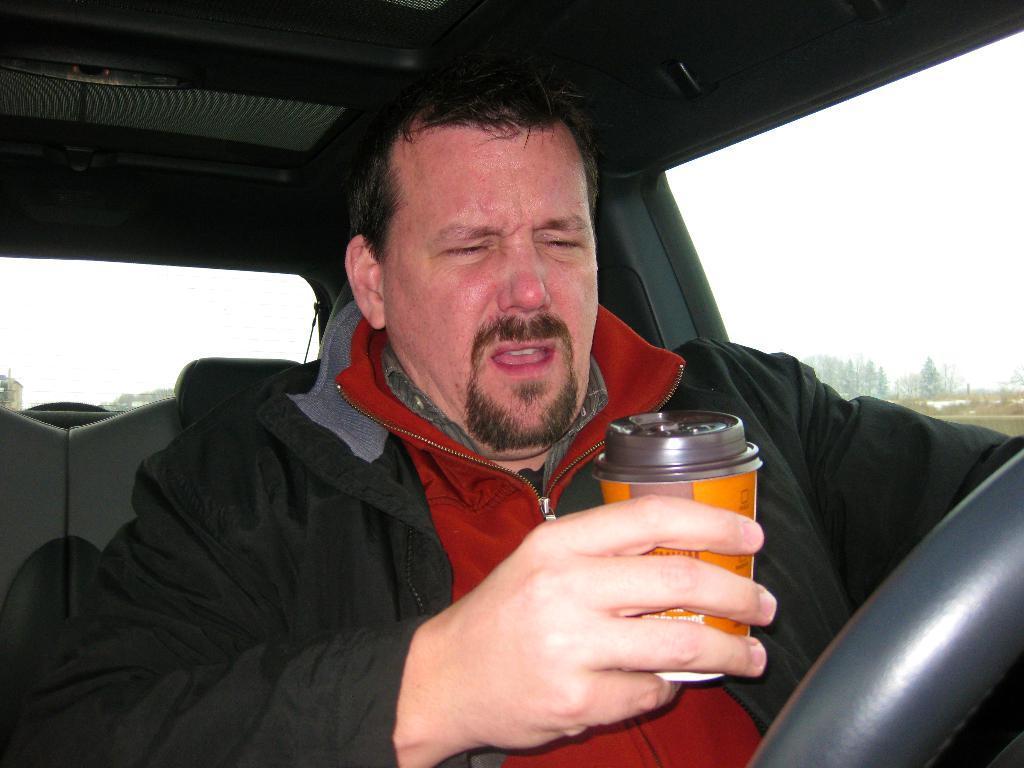Please provide a concise description of this image. he is sitting a car. he is holding like tin on other side of the hand holding like a steering. He is crying also since we see him mouth is open here. Other side we have trees and sky. 